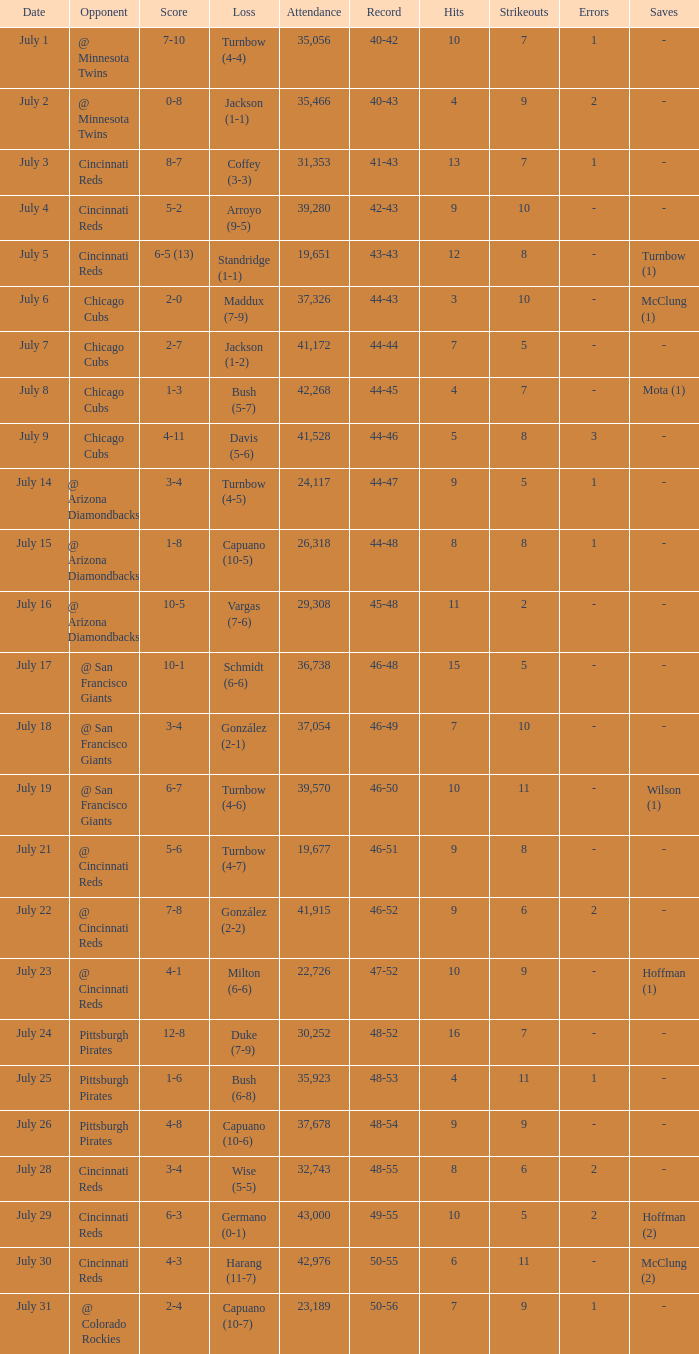What was the loss of the Brewers game when the record was 46-48? Schmidt (6-6). 